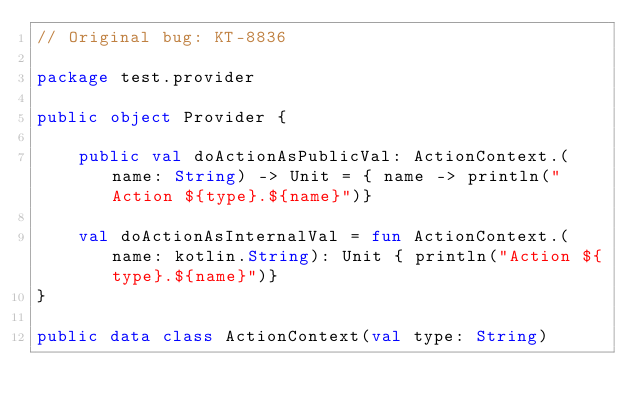<code> <loc_0><loc_0><loc_500><loc_500><_Kotlin_>// Original bug: KT-8836

package test.provider

public object Provider {

    public val doActionAsPublicVal: ActionContext.(name: String) -> Unit = { name -> println("Action ${type}.${name}")}

    val doActionAsInternalVal = fun ActionContext.(name: kotlin.String): Unit { println("Action ${type}.${name}")}
}

public data class ActionContext(val type: String)
</code> 